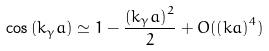Convert formula to latex. <formula><loc_0><loc_0><loc_500><loc_500>\cos \left ( k _ { \gamma } a \right ) & \simeq 1 - \frac { \left ( k _ { \gamma } a \right ) ^ { 2 } } { 2 } + O ( \left ( k a \right ) ^ { 4 } )</formula> 